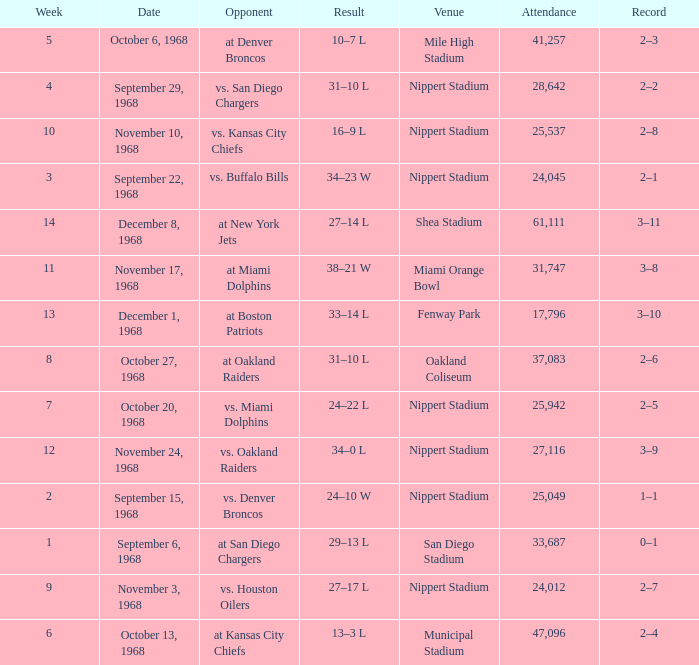What date was the week 6 game played on? October 13, 1968. 